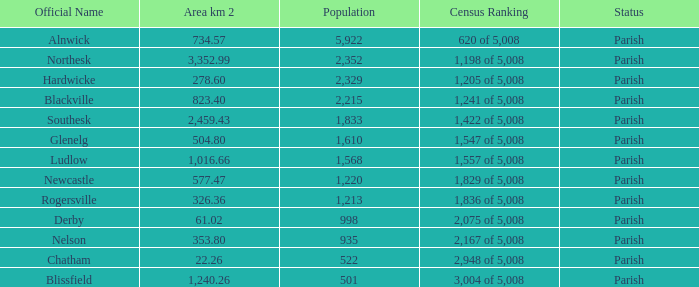Can you tell me the sum of Area km 2 that has the Official Name of glenelg? 504.8. 